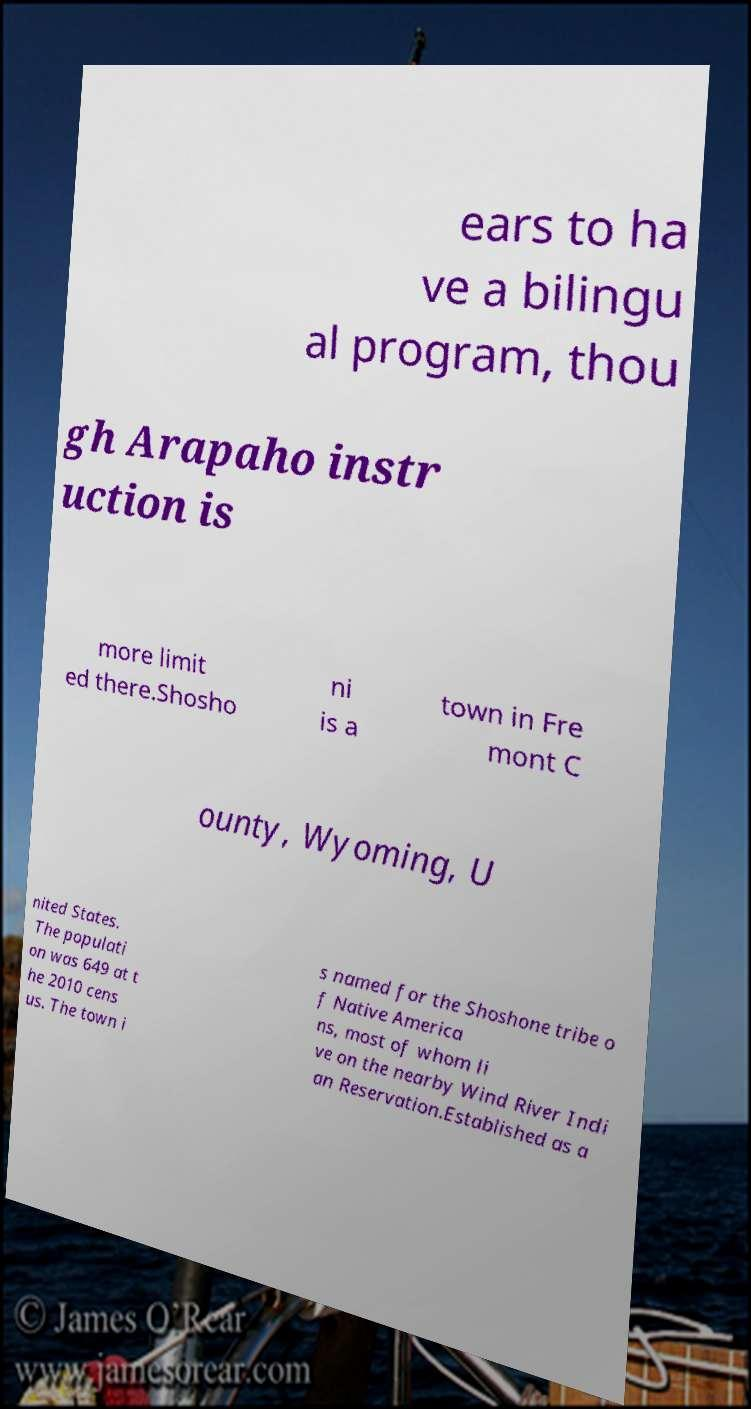What messages or text are displayed in this image? I need them in a readable, typed format. ears to ha ve a bilingu al program, thou gh Arapaho instr uction is more limit ed there.Shosho ni is a town in Fre mont C ounty, Wyoming, U nited States. The populati on was 649 at t he 2010 cens us. The town i s named for the Shoshone tribe o f Native America ns, most of whom li ve on the nearby Wind River Indi an Reservation.Established as a 